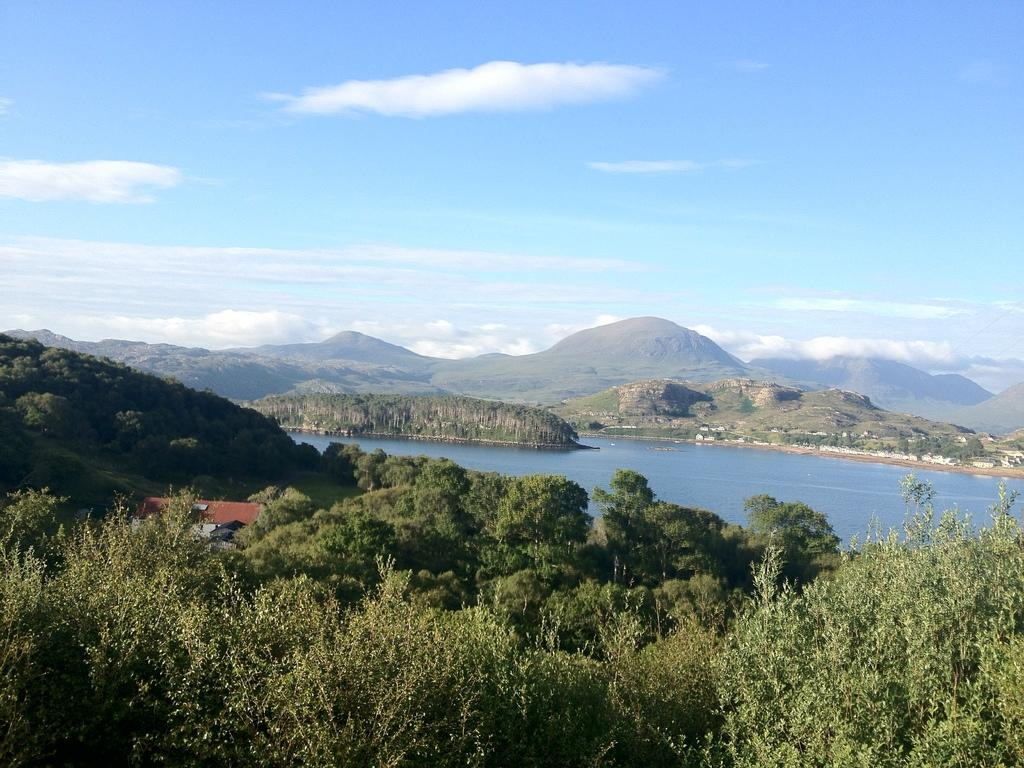What type of natural environment is depicted in the image? There are many trees in the image, suggesting a forest or wooded area. What type of structure can be seen in the image? There is a roof of a building visible in the image. What can be seen in the distance in the image? There is water, hills, and the sky visible in the background of the image. What is the condition of the sky in the image? Clouds are present in the sky in the image. What type of pie is being served by the servant in the image? There is no servant or pie present in the image. What type of work is being done by the people in the image? There are no people or work-related activities depicted in the image. 